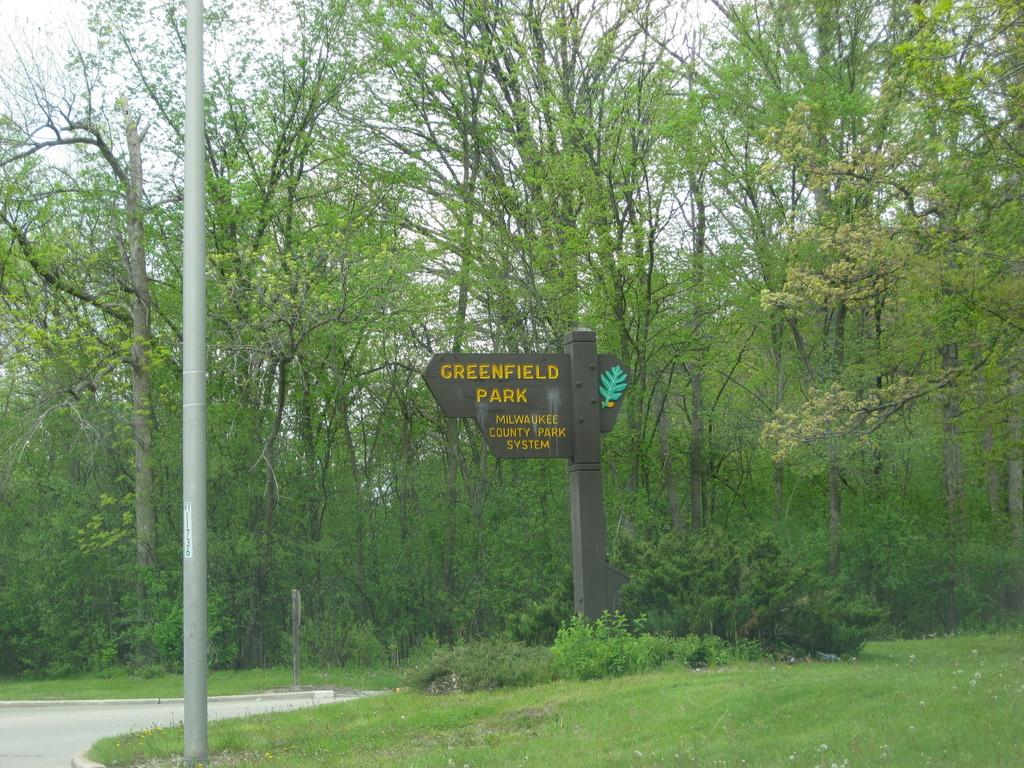What is the main structure in the image? There is a pole in the image. What is located near the pole? There is a road and grass in the image. What else can be seen on the ground in the image? There are plants on the ground in the image. What is written on the pole? There are texts written on a board on the pole. What can be seen in the background of the image? There are trees and clouds in the sky in the background of the image. What type of juice is being served in the image? There is no juice being served in the image; it features a pole with a board and surrounding environment. What type of body is visible in the image? There is no body visible in the image; it only shows a pole, road, grass, plants, and background elements. 